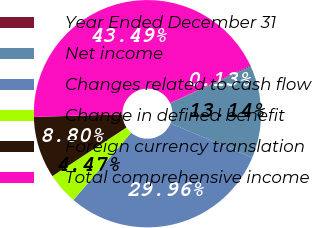<chart> <loc_0><loc_0><loc_500><loc_500><pie_chart><fcel>Year Ended December 31<fcel>Net income<fcel>Changes related to cash flow<fcel>Change in defined benefit<fcel>Foreign currency translation<fcel>Total comprehensive income<nl><fcel>0.13%<fcel>13.14%<fcel>29.96%<fcel>4.47%<fcel>8.8%<fcel>43.49%<nl></chart> 